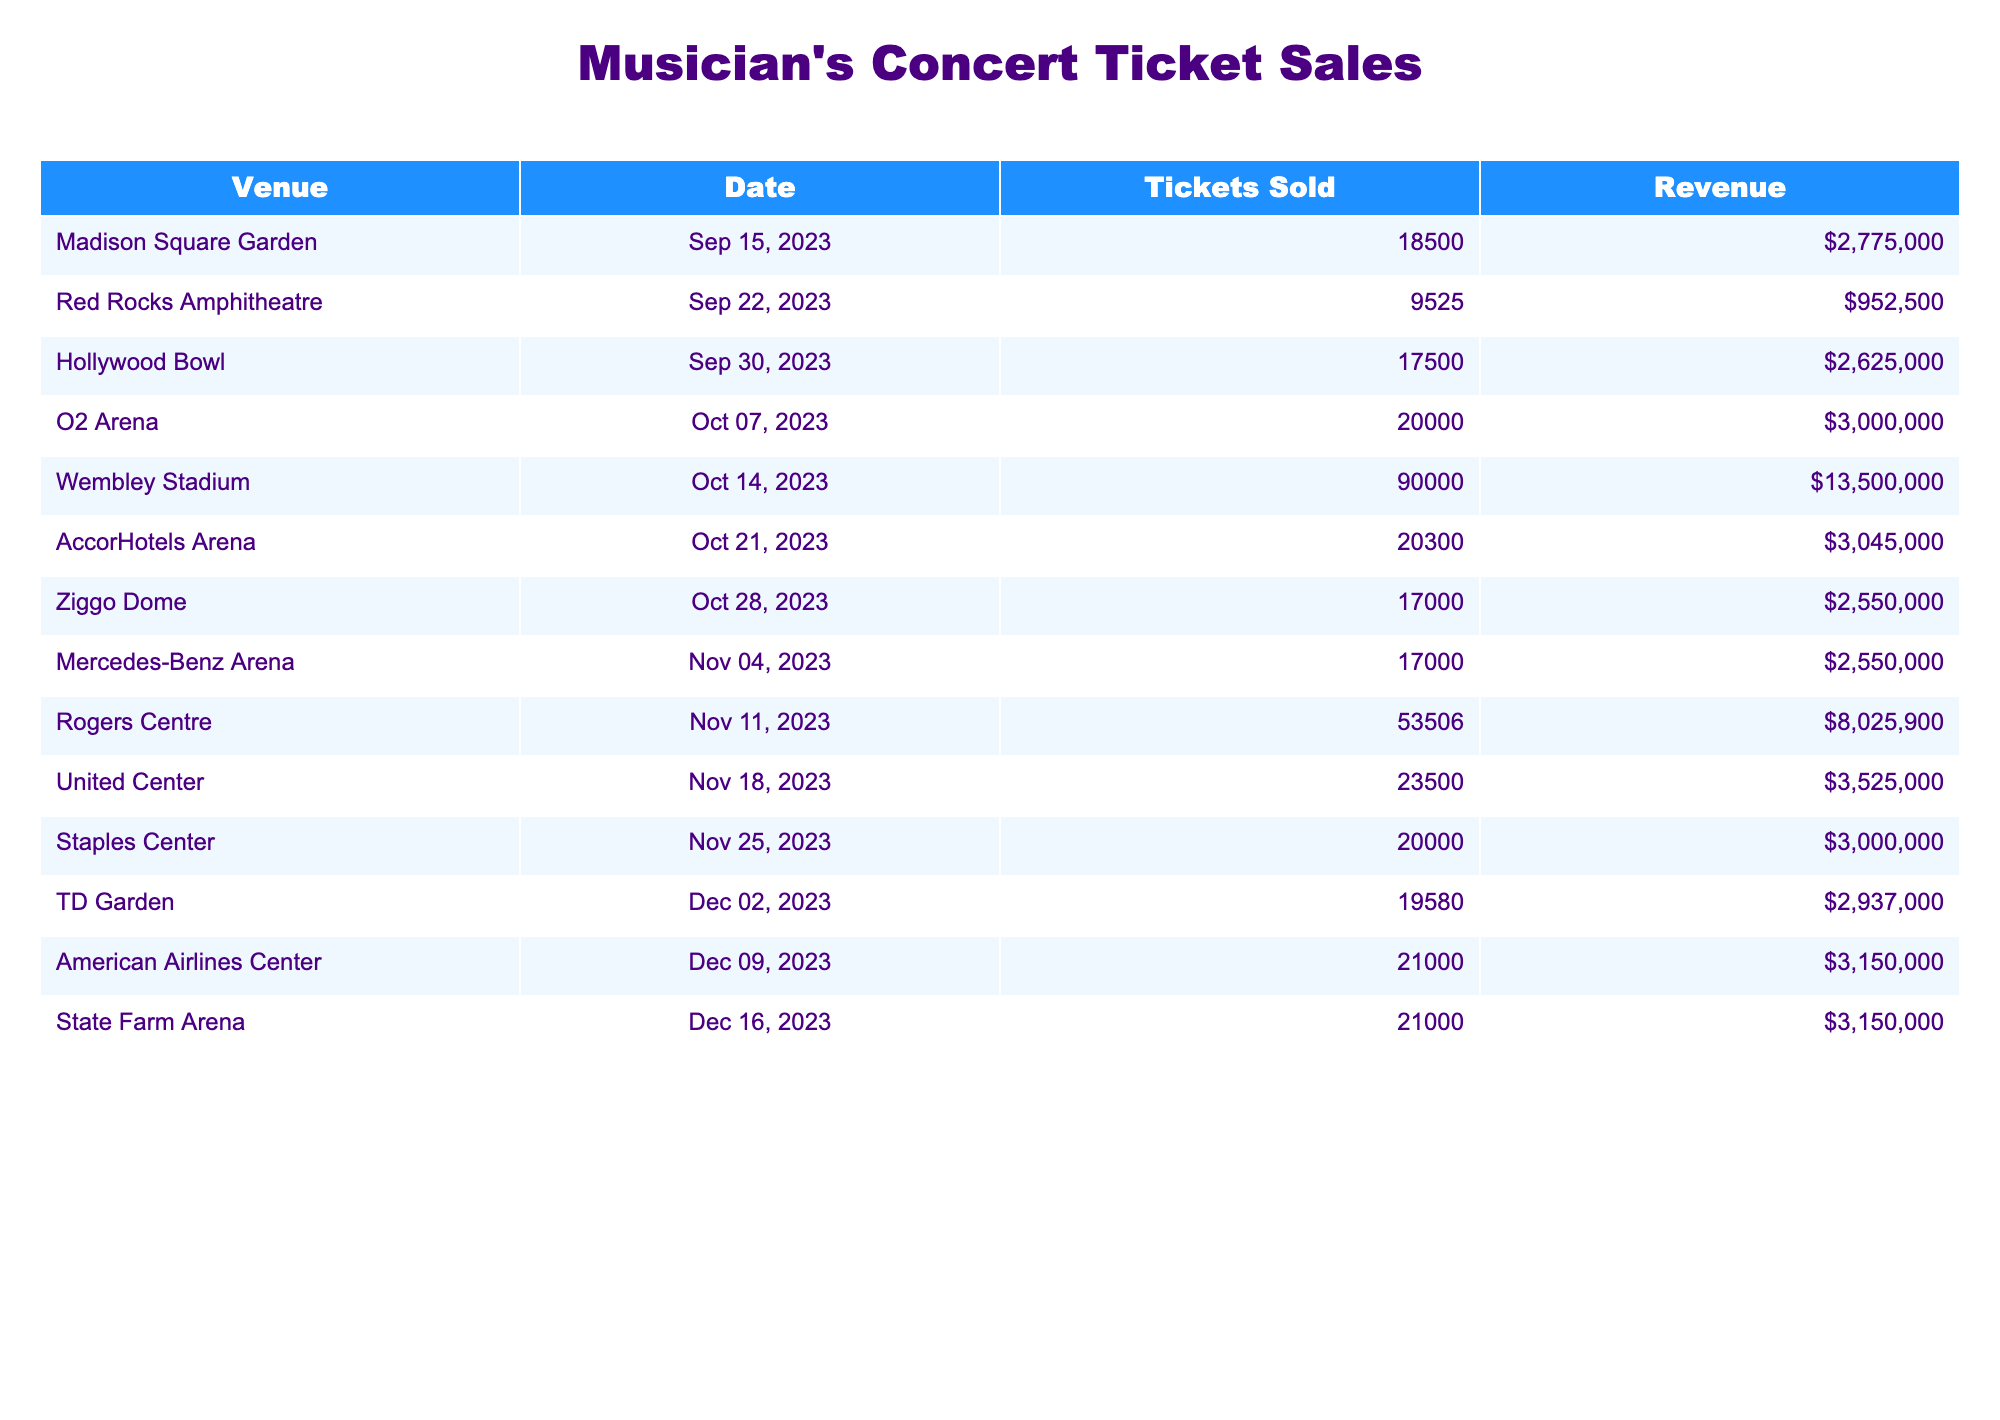What is the total number of tickets sold across all venues? To find the total tickets sold, we add the number of tickets sold at each venue: 18500 + 9525 + 17500 + 20000 + 90000 + 20300 + 17000 + 17000 + 53506 + 23500 + 20000 + 19580 + 21000 + 21000 = 449511.
Answer: 449511 Which venue sold the most tickets? By comparing the 'Tickets Sold' column, Wembley Stadium has the highest value of 90000 tickets sold.
Answer: Wembley Stadium What was the total revenue generated from the concerts? We calculate the total revenue by summing up the revenue from each venue: $2775000 + $952500 + $2625000 + $3000000 + $13500000 + $3045000 + $2550000 + $2550000 + $8025900 + $3525000 + $3000000 + $2937000 + $3150000 + $3150000 = $  25,422,900.
Answer: $25,422,900 How many more tickets were sold at Wembley Stadium than at Red Rocks Amphitheatre? We subtract the number of tickets sold at Red Rocks Amphitheatre (9525) from Wembley Stadium (90000): 90000 - 9525 = 80475.
Answer: 80475 What is the average number of tickets sold per venue? To find the average, we sum the tickets sold (449511) and divide by the number of venues (13): 449511 / 13 = 34653.
Answer: 34653 Did the Hollywood Bowl generate more revenue than the AccorHotels Arena? We compare the revenue for Hollywood Bowl ($2625000) and AccorHotels Arena ($3045000) and see that the latter is greater, so the statement is false.
Answer: False Which date had the highest ticket sales? By inspecting the 'Date' column along with 'Tickets Sold', we find that Wembley Stadium sold the most tickets (90000) on 2023-10-14, making it the highest sales date.
Answer: 2023-10-14 What is the difference in revenue between the top-selling venue and the venue with the least tickets sold? We find the top-selling venue is Wembley Stadium with $13500000 and the venue with the least sales is Red Rocks Amphitheatre with $952500. The difference is $13500000 - $952500 = $12547500.
Answer: $12547500 How many venues sold more than 20000 tickets? By counting the venues with ticket sales above 20000, we identify O2 Arena, Wembley Stadium, AccorHotels Arena, and Rogers Centre, totaling 5 venues.
Answer: 5 What percentage of the total tickets sold were from Madison Square Garden? The tickets sold at Madison Square Garden is 18500. We compute its percentage of total tickets by (18500 / 449511) * 100 = 4.12%.
Answer: 4.12% 